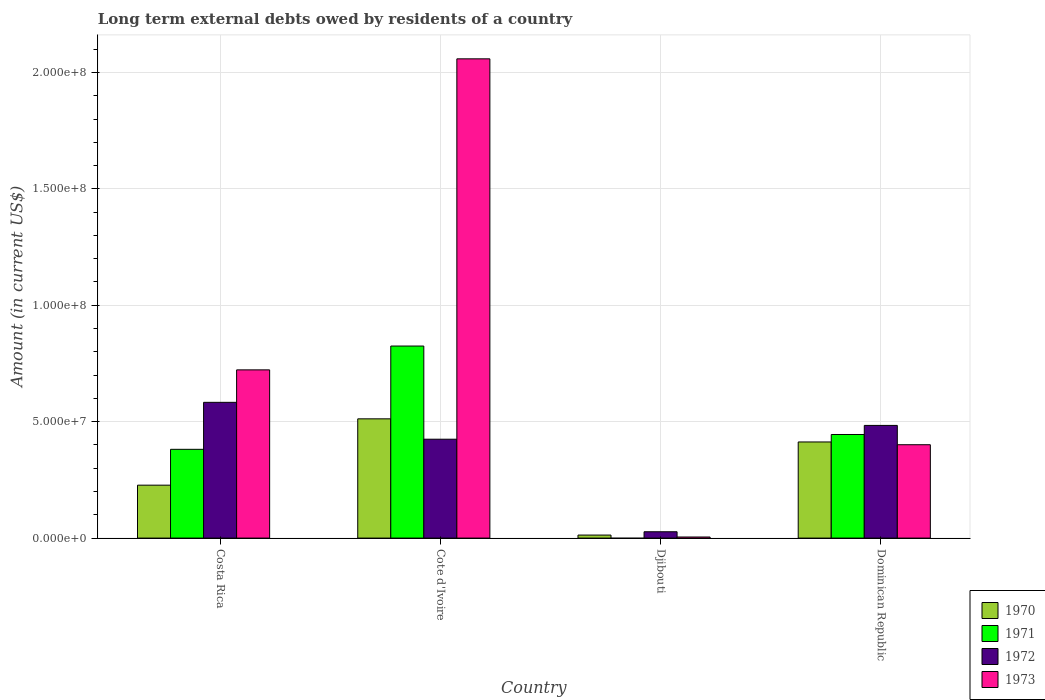Are the number of bars per tick equal to the number of legend labels?
Offer a very short reply. No. Are the number of bars on each tick of the X-axis equal?
Offer a terse response. No. How many bars are there on the 4th tick from the left?
Give a very brief answer. 4. How many bars are there on the 1st tick from the right?
Offer a terse response. 4. What is the label of the 3rd group of bars from the left?
Make the answer very short. Djibouti. In how many cases, is the number of bars for a given country not equal to the number of legend labels?
Your answer should be very brief. 1. What is the amount of long-term external debts owed by residents in 1972 in Costa Rica?
Your answer should be compact. 5.83e+07. Across all countries, what is the maximum amount of long-term external debts owed by residents in 1973?
Your answer should be compact. 2.06e+08. Across all countries, what is the minimum amount of long-term external debts owed by residents in 1973?
Ensure brevity in your answer.  4.68e+05. In which country was the amount of long-term external debts owed by residents in 1972 maximum?
Your answer should be very brief. Costa Rica. What is the total amount of long-term external debts owed by residents in 1973 in the graph?
Your answer should be compact. 3.19e+08. What is the difference between the amount of long-term external debts owed by residents in 1970 in Costa Rica and that in Djibouti?
Your response must be concise. 2.14e+07. What is the difference between the amount of long-term external debts owed by residents in 1972 in Djibouti and the amount of long-term external debts owed by residents in 1973 in Dominican Republic?
Keep it short and to the point. -3.74e+07. What is the average amount of long-term external debts owed by residents in 1971 per country?
Offer a very short reply. 4.13e+07. What is the difference between the amount of long-term external debts owed by residents of/in 1972 and amount of long-term external debts owed by residents of/in 1973 in Djibouti?
Your answer should be compact. 2.26e+06. In how many countries, is the amount of long-term external debts owed by residents in 1971 greater than 170000000 US$?
Give a very brief answer. 0. What is the ratio of the amount of long-term external debts owed by residents in 1973 in Cote d'Ivoire to that in Djibouti?
Offer a terse response. 439.86. Is the amount of long-term external debts owed by residents in 1971 in Cote d'Ivoire less than that in Dominican Republic?
Ensure brevity in your answer.  No. What is the difference between the highest and the second highest amount of long-term external debts owed by residents in 1973?
Keep it short and to the point. 1.34e+08. What is the difference between the highest and the lowest amount of long-term external debts owed by residents in 1971?
Provide a succinct answer. 8.25e+07. In how many countries, is the amount of long-term external debts owed by residents in 1970 greater than the average amount of long-term external debts owed by residents in 1970 taken over all countries?
Offer a very short reply. 2. Is it the case that in every country, the sum of the amount of long-term external debts owed by residents in 1970 and amount of long-term external debts owed by residents in 1973 is greater than the sum of amount of long-term external debts owed by residents in 1972 and amount of long-term external debts owed by residents in 1971?
Ensure brevity in your answer.  No. How many bars are there?
Offer a very short reply. 15. Are all the bars in the graph horizontal?
Provide a short and direct response. No. How many countries are there in the graph?
Provide a succinct answer. 4. What is the difference between two consecutive major ticks on the Y-axis?
Your response must be concise. 5.00e+07. Does the graph contain grids?
Provide a short and direct response. Yes. Where does the legend appear in the graph?
Provide a succinct answer. Bottom right. How are the legend labels stacked?
Your answer should be very brief. Vertical. What is the title of the graph?
Make the answer very short. Long term external debts owed by residents of a country. Does "2014" appear as one of the legend labels in the graph?
Keep it short and to the point. No. What is the label or title of the X-axis?
Provide a succinct answer. Country. What is the label or title of the Y-axis?
Give a very brief answer. Amount (in current US$). What is the Amount (in current US$) of 1970 in Costa Rica?
Offer a terse response. 2.27e+07. What is the Amount (in current US$) of 1971 in Costa Rica?
Ensure brevity in your answer.  3.81e+07. What is the Amount (in current US$) in 1972 in Costa Rica?
Provide a succinct answer. 5.83e+07. What is the Amount (in current US$) in 1973 in Costa Rica?
Give a very brief answer. 7.23e+07. What is the Amount (in current US$) of 1970 in Cote d'Ivoire?
Your answer should be very brief. 5.12e+07. What is the Amount (in current US$) in 1971 in Cote d'Ivoire?
Make the answer very short. 8.25e+07. What is the Amount (in current US$) of 1972 in Cote d'Ivoire?
Provide a succinct answer. 4.25e+07. What is the Amount (in current US$) in 1973 in Cote d'Ivoire?
Keep it short and to the point. 2.06e+08. What is the Amount (in current US$) in 1970 in Djibouti?
Provide a short and direct response. 1.30e+06. What is the Amount (in current US$) of 1971 in Djibouti?
Provide a short and direct response. 0. What is the Amount (in current US$) in 1972 in Djibouti?
Your response must be concise. 2.72e+06. What is the Amount (in current US$) of 1973 in Djibouti?
Provide a short and direct response. 4.68e+05. What is the Amount (in current US$) in 1970 in Dominican Republic?
Your answer should be compact. 4.13e+07. What is the Amount (in current US$) in 1971 in Dominican Republic?
Offer a terse response. 4.45e+07. What is the Amount (in current US$) in 1972 in Dominican Republic?
Your answer should be compact. 4.84e+07. What is the Amount (in current US$) in 1973 in Dominican Republic?
Provide a short and direct response. 4.01e+07. Across all countries, what is the maximum Amount (in current US$) of 1970?
Your answer should be compact. 5.12e+07. Across all countries, what is the maximum Amount (in current US$) in 1971?
Make the answer very short. 8.25e+07. Across all countries, what is the maximum Amount (in current US$) of 1972?
Offer a terse response. 5.83e+07. Across all countries, what is the maximum Amount (in current US$) of 1973?
Your answer should be very brief. 2.06e+08. Across all countries, what is the minimum Amount (in current US$) in 1970?
Your answer should be compact. 1.30e+06. Across all countries, what is the minimum Amount (in current US$) in 1972?
Offer a terse response. 2.72e+06. Across all countries, what is the minimum Amount (in current US$) of 1973?
Keep it short and to the point. 4.68e+05. What is the total Amount (in current US$) in 1970 in the graph?
Offer a terse response. 1.17e+08. What is the total Amount (in current US$) of 1971 in the graph?
Your answer should be very brief. 1.65e+08. What is the total Amount (in current US$) in 1972 in the graph?
Make the answer very short. 1.52e+08. What is the total Amount (in current US$) in 1973 in the graph?
Offer a very short reply. 3.19e+08. What is the difference between the Amount (in current US$) of 1970 in Costa Rica and that in Cote d'Ivoire?
Give a very brief answer. -2.85e+07. What is the difference between the Amount (in current US$) in 1971 in Costa Rica and that in Cote d'Ivoire?
Ensure brevity in your answer.  -4.44e+07. What is the difference between the Amount (in current US$) of 1972 in Costa Rica and that in Cote d'Ivoire?
Your answer should be compact. 1.58e+07. What is the difference between the Amount (in current US$) in 1973 in Costa Rica and that in Cote d'Ivoire?
Keep it short and to the point. -1.34e+08. What is the difference between the Amount (in current US$) of 1970 in Costa Rica and that in Djibouti?
Your response must be concise. 2.14e+07. What is the difference between the Amount (in current US$) in 1972 in Costa Rica and that in Djibouti?
Provide a short and direct response. 5.56e+07. What is the difference between the Amount (in current US$) of 1973 in Costa Rica and that in Djibouti?
Offer a terse response. 7.18e+07. What is the difference between the Amount (in current US$) of 1970 in Costa Rica and that in Dominican Republic?
Offer a terse response. -1.86e+07. What is the difference between the Amount (in current US$) of 1971 in Costa Rica and that in Dominican Republic?
Provide a short and direct response. -6.37e+06. What is the difference between the Amount (in current US$) in 1972 in Costa Rica and that in Dominican Republic?
Keep it short and to the point. 9.92e+06. What is the difference between the Amount (in current US$) in 1973 in Costa Rica and that in Dominican Republic?
Provide a succinct answer. 3.22e+07. What is the difference between the Amount (in current US$) of 1970 in Cote d'Ivoire and that in Djibouti?
Make the answer very short. 4.99e+07. What is the difference between the Amount (in current US$) in 1972 in Cote d'Ivoire and that in Djibouti?
Your answer should be very brief. 3.98e+07. What is the difference between the Amount (in current US$) in 1973 in Cote d'Ivoire and that in Djibouti?
Keep it short and to the point. 2.05e+08. What is the difference between the Amount (in current US$) in 1970 in Cote d'Ivoire and that in Dominican Republic?
Your response must be concise. 9.93e+06. What is the difference between the Amount (in current US$) in 1971 in Cote d'Ivoire and that in Dominican Republic?
Your answer should be very brief. 3.80e+07. What is the difference between the Amount (in current US$) of 1972 in Cote d'Ivoire and that in Dominican Republic?
Offer a terse response. -5.92e+06. What is the difference between the Amount (in current US$) in 1973 in Cote d'Ivoire and that in Dominican Republic?
Ensure brevity in your answer.  1.66e+08. What is the difference between the Amount (in current US$) in 1970 in Djibouti and that in Dominican Republic?
Keep it short and to the point. -4.00e+07. What is the difference between the Amount (in current US$) in 1972 in Djibouti and that in Dominican Republic?
Offer a very short reply. -4.57e+07. What is the difference between the Amount (in current US$) in 1973 in Djibouti and that in Dominican Republic?
Keep it short and to the point. -3.96e+07. What is the difference between the Amount (in current US$) in 1970 in Costa Rica and the Amount (in current US$) in 1971 in Cote d'Ivoire?
Offer a terse response. -5.98e+07. What is the difference between the Amount (in current US$) in 1970 in Costa Rica and the Amount (in current US$) in 1972 in Cote d'Ivoire?
Keep it short and to the point. -1.97e+07. What is the difference between the Amount (in current US$) in 1970 in Costa Rica and the Amount (in current US$) in 1973 in Cote d'Ivoire?
Your answer should be compact. -1.83e+08. What is the difference between the Amount (in current US$) in 1971 in Costa Rica and the Amount (in current US$) in 1972 in Cote d'Ivoire?
Make the answer very short. -4.34e+06. What is the difference between the Amount (in current US$) in 1971 in Costa Rica and the Amount (in current US$) in 1973 in Cote d'Ivoire?
Your response must be concise. -1.68e+08. What is the difference between the Amount (in current US$) in 1972 in Costa Rica and the Amount (in current US$) in 1973 in Cote d'Ivoire?
Keep it short and to the point. -1.48e+08. What is the difference between the Amount (in current US$) in 1970 in Costa Rica and the Amount (in current US$) in 1972 in Djibouti?
Keep it short and to the point. 2.00e+07. What is the difference between the Amount (in current US$) in 1970 in Costa Rica and the Amount (in current US$) in 1973 in Djibouti?
Your response must be concise. 2.23e+07. What is the difference between the Amount (in current US$) in 1971 in Costa Rica and the Amount (in current US$) in 1972 in Djibouti?
Offer a terse response. 3.54e+07. What is the difference between the Amount (in current US$) of 1971 in Costa Rica and the Amount (in current US$) of 1973 in Djibouti?
Your answer should be compact. 3.77e+07. What is the difference between the Amount (in current US$) in 1972 in Costa Rica and the Amount (in current US$) in 1973 in Djibouti?
Keep it short and to the point. 5.78e+07. What is the difference between the Amount (in current US$) in 1970 in Costa Rica and the Amount (in current US$) in 1971 in Dominican Republic?
Offer a very short reply. -2.18e+07. What is the difference between the Amount (in current US$) of 1970 in Costa Rica and the Amount (in current US$) of 1972 in Dominican Republic?
Provide a succinct answer. -2.57e+07. What is the difference between the Amount (in current US$) of 1970 in Costa Rica and the Amount (in current US$) of 1973 in Dominican Republic?
Offer a terse response. -1.74e+07. What is the difference between the Amount (in current US$) in 1971 in Costa Rica and the Amount (in current US$) in 1972 in Dominican Republic?
Make the answer very short. -1.03e+07. What is the difference between the Amount (in current US$) in 1971 in Costa Rica and the Amount (in current US$) in 1973 in Dominican Republic?
Offer a very short reply. -1.97e+06. What is the difference between the Amount (in current US$) in 1972 in Costa Rica and the Amount (in current US$) in 1973 in Dominican Republic?
Give a very brief answer. 1.82e+07. What is the difference between the Amount (in current US$) of 1970 in Cote d'Ivoire and the Amount (in current US$) of 1972 in Djibouti?
Ensure brevity in your answer.  4.85e+07. What is the difference between the Amount (in current US$) of 1970 in Cote d'Ivoire and the Amount (in current US$) of 1973 in Djibouti?
Provide a short and direct response. 5.08e+07. What is the difference between the Amount (in current US$) of 1971 in Cote d'Ivoire and the Amount (in current US$) of 1972 in Djibouti?
Provide a short and direct response. 7.98e+07. What is the difference between the Amount (in current US$) in 1971 in Cote d'Ivoire and the Amount (in current US$) in 1973 in Djibouti?
Your response must be concise. 8.20e+07. What is the difference between the Amount (in current US$) of 1972 in Cote d'Ivoire and the Amount (in current US$) of 1973 in Djibouti?
Give a very brief answer. 4.20e+07. What is the difference between the Amount (in current US$) of 1970 in Cote d'Ivoire and the Amount (in current US$) of 1971 in Dominican Republic?
Offer a terse response. 6.73e+06. What is the difference between the Amount (in current US$) of 1970 in Cote d'Ivoire and the Amount (in current US$) of 1972 in Dominican Republic?
Your answer should be very brief. 2.83e+06. What is the difference between the Amount (in current US$) of 1970 in Cote d'Ivoire and the Amount (in current US$) of 1973 in Dominican Republic?
Ensure brevity in your answer.  1.11e+07. What is the difference between the Amount (in current US$) in 1971 in Cote d'Ivoire and the Amount (in current US$) in 1972 in Dominican Republic?
Offer a terse response. 3.41e+07. What is the difference between the Amount (in current US$) in 1971 in Cote d'Ivoire and the Amount (in current US$) in 1973 in Dominican Republic?
Ensure brevity in your answer.  4.24e+07. What is the difference between the Amount (in current US$) of 1972 in Cote d'Ivoire and the Amount (in current US$) of 1973 in Dominican Republic?
Offer a very short reply. 2.37e+06. What is the difference between the Amount (in current US$) of 1970 in Djibouti and the Amount (in current US$) of 1971 in Dominican Republic?
Your response must be concise. -4.32e+07. What is the difference between the Amount (in current US$) of 1970 in Djibouti and the Amount (in current US$) of 1972 in Dominican Republic?
Ensure brevity in your answer.  -4.71e+07. What is the difference between the Amount (in current US$) in 1970 in Djibouti and the Amount (in current US$) in 1973 in Dominican Republic?
Your answer should be compact. -3.88e+07. What is the difference between the Amount (in current US$) in 1972 in Djibouti and the Amount (in current US$) in 1973 in Dominican Republic?
Ensure brevity in your answer.  -3.74e+07. What is the average Amount (in current US$) of 1970 per country?
Offer a terse response. 2.91e+07. What is the average Amount (in current US$) in 1971 per country?
Ensure brevity in your answer.  4.13e+07. What is the average Amount (in current US$) in 1972 per country?
Offer a terse response. 3.80e+07. What is the average Amount (in current US$) of 1973 per country?
Offer a terse response. 7.97e+07. What is the difference between the Amount (in current US$) in 1970 and Amount (in current US$) in 1971 in Costa Rica?
Provide a short and direct response. -1.54e+07. What is the difference between the Amount (in current US$) in 1970 and Amount (in current US$) in 1972 in Costa Rica?
Your answer should be very brief. -3.56e+07. What is the difference between the Amount (in current US$) in 1970 and Amount (in current US$) in 1973 in Costa Rica?
Keep it short and to the point. -4.95e+07. What is the difference between the Amount (in current US$) of 1971 and Amount (in current US$) of 1972 in Costa Rica?
Give a very brief answer. -2.02e+07. What is the difference between the Amount (in current US$) of 1971 and Amount (in current US$) of 1973 in Costa Rica?
Provide a short and direct response. -3.41e+07. What is the difference between the Amount (in current US$) in 1972 and Amount (in current US$) in 1973 in Costa Rica?
Give a very brief answer. -1.39e+07. What is the difference between the Amount (in current US$) in 1970 and Amount (in current US$) in 1971 in Cote d'Ivoire?
Provide a short and direct response. -3.13e+07. What is the difference between the Amount (in current US$) of 1970 and Amount (in current US$) of 1972 in Cote d'Ivoire?
Your response must be concise. 8.75e+06. What is the difference between the Amount (in current US$) of 1970 and Amount (in current US$) of 1973 in Cote d'Ivoire?
Ensure brevity in your answer.  -1.55e+08. What is the difference between the Amount (in current US$) of 1971 and Amount (in current US$) of 1972 in Cote d'Ivoire?
Make the answer very short. 4.00e+07. What is the difference between the Amount (in current US$) of 1971 and Amount (in current US$) of 1973 in Cote d'Ivoire?
Give a very brief answer. -1.23e+08. What is the difference between the Amount (in current US$) in 1972 and Amount (in current US$) in 1973 in Cote d'Ivoire?
Provide a short and direct response. -1.63e+08. What is the difference between the Amount (in current US$) in 1970 and Amount (in current US$) in 1972 in Djibouti?
Your answer should be compact. -1.42e+06. What is the difference between the Amount (in current US$) in 1970 and Amount (in current US$) in 1973 in Djibouti?
Keep it short and to the point. 8.32e+05. What is the difference between the Amount (in current US$) in 1972 and Amount (in current US$) in 1973 in Djibouti?
Your answer should be very brief. 2.26e+06. What is the difference between the Amount (in current US$) in 1970 and Amount (in current US$) in 1971 in Dominican Republic?
Your answer should be very brief. -3.21e+06. What is the difference between the Amount (in current US$) of 1970 and Amount (in current US$) of 1972 in Dominican Republic?
Your answer should be very brief. -7.11e+06. What is the difference between the Amount (in current US$) in 1970 and Amount (in current US$) in 1973 in Dominican Republic?
Your answer should be very brief. 1.19e+06. What is the difference between the Amount (in current US$) of 1971 and Amount (in current US$) of 1972 in Dominican Republic?
Give a very brief answer. -3.90e+06. What is the difference between the Amount (in current US$) of 1971 and Amount (in current US$) of 1973 in Dominican Republic?
Your answer should be very brief. 4.39e+06. What is the difference between the Amount (in current US$) in 1972 and Amount (in current US$) in 1973 in Dominican Republic?
Offer a very short reply. 8.29e+06. What is the ratio of the Amount (in current US$) of 1970 in Costa Rica to that in Cote d'Ivoire?
Provide a succinct answer. 0.44. What is the ratio of the Amount (in current US$) of 1971 in Costa Rica to that in Cote d'Ivoire?
Keep it short and to the point. 0.46. What is the ratio of the Amount (in current US$) of 1972 in Costa Rica to that in Cote d'Ivoire?
Give a very brief answer. 1.37. What is the ratio of the Amount (in current US$) in 1973 in Costa Rica to that in Cote d'Ivoire?
Your answer should be compact. 0.35. What is the ratio of the Amount (in current US$) of 1970 in Costa Rica to that in Djibouti?
Give a very brief answer. 17.49. What is the ratio of the Amount (in current US$) in 1972 in Costa Rica to that in Djibouti?
Offer a very short reply. 21.41. What is the ratio of the Amount (in current US$) in 1973 in Costa Rica to that in Djibouti?
Keep it short and to the point. 154.4. What is the ratio of the Amount (in current US$) in 1970 in Costa Rica to that in Dominican Republic?
Ensure brevity in your answer.  0.55. What is the ratio of the Amount (in current US$) of 1971 in Costa Rica to that in Dominican Republic?
Offer a terse response. 0.86. What is the ratio of the Amount (in current US$) in 1972 in Costa Rica to that in Dominican Republic?
Make the answer very short. 1.2. What is the ratio of the Amount (in current US$) in 1973 in Costa Rica to that in Dominican Republic?
Make the answer very short. 1.8. What is the ratio of the Amount (in current US$) in 1970 in Cote d'Ivoire to that in Djibouti?
Your answer should be very brief. 39.4. What is the ratio of the Amount (in current US$) of 1972 in Cote d'Ivoire to that in Djibouti?
Ensure brevity in your answer.  15.6. What is the ratio of the Amount (in current US$) of 1973 in Cote d'Ivoire to that in Djibouti?
Ensure brevity in your answer.  439.86. What is the ratio of the Amount (in current US$) of 1970 in Cote d'Ivoire to that in Dominican Republic?
Your response must be concise. 1.24. What is the ratio of the Amount (in current US$) of 1971 in Cote d'Ivoire to that in Dominican Republic?
Give a very brief answer. 1.85. What is the ratio of the Amount (in current US$) in 1972 in Cote d'Ivoire to that in Dominican Republic?
Give a very brief answer. 0.88. What is the ratio of the Amount (in current US$) in 1973 in Cote d'Ivoire to that in Dominican Republic?
Your answer should be compact. 5.13. What is the ratio of the Amount (in current US$) in 1970 in Djibouti to that in Dominican Republic?
Provide a short and direct response. 0.03. What is the ratio of the Amount (in current US$) of 1972 in Djibouti to that in Dominican Republic?
Ensure brevity in your answer.  0.06. What is the ratio of the Amount (in current US$) of 1973 in Djibouti to that in Dominican Republic?
Make the answer very short. 0.01. What is the difference between the highest and the second highest Amount (in current US$) in 1970?
Provide a succinct answer. 9.93e+06. What is the difference between the highest and the second highest Amount (in current US$) in 1971?
Your answer should be compact. 3.80e+07. What is the difference between the highest and the second highest Amount (in current US$) of 1972?
Offer a terse response. 9.92e+06. What is the difference between the highest and the second highest Amount (in current US$) of 1973?
Your response must be concise. 1.34e+08. What is the difference between the highest and the lowest Amount (in current US$) in 1970?
Your answer should be very brief. 4.99e+07. What is the difference between the highest and the lowest Amount (in current US$) of 1971?
Your answer should be very brief. 8.25e+07. What is the difference between the highest and the lowest Amount (in current US$) in 1972?
Your answer should be compact. 5.56e+07. What is the difference between the highest and the lowest Amount (in current US$) in 1973?
Make the answer very short. 2.05e+08. 